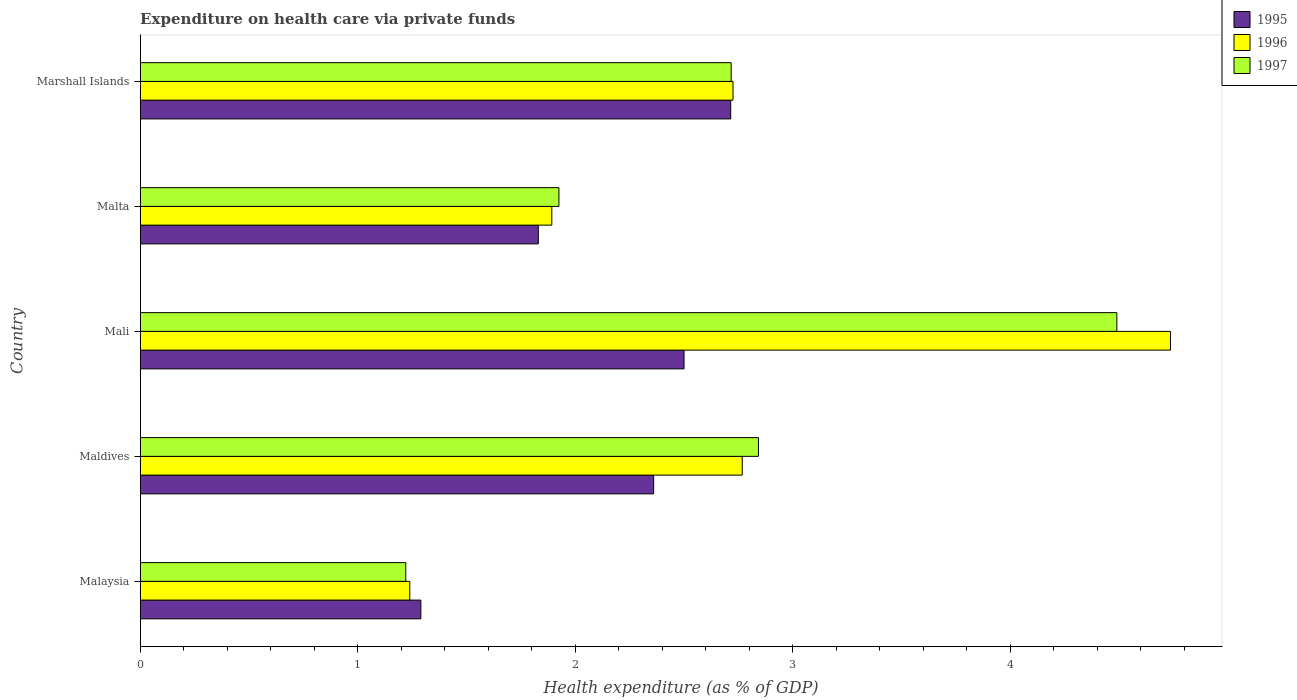How many different coloured bars are there?
Your answer should be very brief. 3. How many groups of bars are there?
Your answer should be very brief. 5. Are the number of bars on each tick of the Y-axis equal?
Your answer should be very brief. Yes. How many bars are there on the 5th tick from the bottom?
Provide a succinct answer. 3. What is the label of the 1st group of bars from the top?
Offer a terse response. Marshall Islands. In how many cases, is the number of bars for a given country not equal to the number of legend labels?
Your answer should be compact. 0. What is the expenditure made on health care in 1997 in Malta?
Offer a very short reply. 1.93. Across all countries, what is the maximum expenditure made on health care in 1997?
Your answer should be compact. 4.49. Across all countries, what is the minimum expenditure made on health care in 1996?
Provide a short and direct response. 1.24. In which country was the expenditure made on health care in 1996 maximum?
Your answer should be very brief. Mali. In which country was the expenditure made on health care in 1996 minimum?
Give a very brief answer. Malaysia. What is the total expenditure made on health care in 1997 in the graph?
Make the answer very short. 13.2. What is the difference between the expenditure made on health care in 1997 in Mali and that in Marshall Islands?
Ensure brevity in your answer.  1.77. What is the difference between the expenditure made on health care in 1996 in Marshall Islands and the expenditure made on health care in 1995 in Malaysia?
Give a very brief answer. 1.44. What is the average expenditure made on health care in 1996 per country?
Your answer should be very brief. 2.67. What is the difference between the expenditure made on health care in 1995 and expenditure made on health care in 1996 in Maldives?
Offer a very short reply. -0.41. In how many countries, is the expenditure made on health care in 1995 greater than 3 %?
Your response must be concise. 0. What is the ratio of the expenditure made on health care in 1996 in Malaysia to that in Maldives?
Your answer should be compact. 0.45. Is the difference between the expenditure made on health care in 1995 in Malaysia and Mali greater than the difference between the expenditure made on health care in 1996 in Malaysia and Mali?
Your answer should be very brief. Yes. What is the difference between the highest and the second highest expenditure made on health care in 1995?
Offer a very short reply. 0.21. What is the difference between the highest and the lowest expenditure made on health care in 1996?
Provide a short and direct response. 3.5. In how many countries, is the expenditure made on health care in 1997 greater than the average expenditure made on health care in 1997 taken over all countries?
Offer a very short reply. 3. Is it the case that in every country, the sum of the expenditure made on health care in 1996 and expenditure made on health care in 1995 is greater than the expenditure made on health care in 1997?
Make the answer very short. Yes. How many bars are there?
Offer a terse response. 15. Are all the bars in the graph horizontal?
Your response must be concise. Yes. How many countries are there in the graph?
Offer a terse response. 5. Does the graph contain grids?
Ensure brevity in your answer.  No. How are the legend labels stacked?
Your answer should be very brief. Vertical. What is the title of the graph?
Ensure brevity in your answer.  Expenditure on health care via private funds. Does "1983" appear as one of the legend labels in the graph?
Provide a succinct answer. No. What is the label or title of the X-axis?
Provide a short and direct response. Health expenditure (as % of GDP). What is the Health expenditure (as % of GDP) in 1995 in Malaysia?
Offer a very short reply. 1.29. What is the Health expenditure (as % of GDP) in 1996 in Malaysia?
Offer a terse response. 1.24. What is the Health expenditure (as % of GDP) of 1997 in Malaysia?
Ensure brevity in your answer.  1.22. What is the Health expenditure (as % of GDP) in 1995 in Maldives?
Ensure brevity in your answer.  2.36. What is the Health expenditure (as % of GDP) of 1996 in Maldives?
Offer a terse response. 2.77. What is the Health expenditure (as % of GDP) of 1997 in Maldives?
Offer a terse response. 2.84. What is the Health expenditure (as % of GDP) in 1995 in Mali?
Give a very brief answer. 2.5. What is the Health expenditure (as % of GDP) of 1996 in Mali?
Give a very brief answer. 4.74. What is the Health expenditure (as % of GDP) in 1997 in Mali?
Offer a terse response. 4.49. What is the Health expenditure (as % of GDP) of 1995 in Malta?
Provide a succinct answer. 1.83. What is the Health expenditure (as % of GDP) of 1996 in Malta?
Provide a short and direct response. 1.89. What is the Health expenditure (as % of GDP) of 1997 in Malta?
Make the answer very short. 1.93. What is the Health expenditure (as % of GDP) in 1995 in Marshall Islands?
Keep it short and to the point. 2.72. What is the Health expenditure (as % of GDP) of 1996 in Marshall Islands?
Your answer should be very brief. 2.73. What is the Health expenditure (as % of GDP) in 1997 in Marshall Islands?
Offer a terse response. 2.72. Across all countries, what is the maximum Health expenditure (as % of GDP) of 1995?
Provide a succinct answer. 2.72. Across all countries, what is the maximum Health expenditure (as % of GDP) in 1996?
Your answer should be compact. 4.74. Across all countries, what is the maximum Health expenditure (as % of GDP) of 1997?
Offer a terse response. 4.49. Across all countries, what is the minimum Health expenditure (as % of GDP) in 1995?
Give a very brief answer. 1.29. Across all countries, what is the minimum Health expenditure (as % of GDP) of 1996?
Provide a succinct answer. 1.24. Across all countries, what is the minimum Health expenditure (as % of GDP) of 1997?
Make the answer very short. 1.22. What is the total Health expenditure (as % of GDP) of 1995 in the graph?
Keep it short and to the point. 10.7. What is the total Health expenditure (as % of GDP) in 1996 in the graph?
Offer a very short reply. 13.36. What is the total Health expenditure (as % of GDP) in 1997 in the graph?
Offer a terse response. 13.2. What is the difference between the Health expenditure (as % of GDP) of 1995 in Malaysia and that in Maldives?
Keep it short and to the point. -1.07. What is the difference between the Health expenditure (as % of GDP) in 1996 in Malaysia and that in Maldives?
Your answer should be very brief. -1.53. What is the difference between the Health expenditure (as % of GDP) of 1997 in Malaysia and that in Maldives?
Make the answer very short. -1.62. What is the difference between the Health expenditure (as % of GDP) of 1995 in Malaysia and that in Mali?
Your response must be concise. -1.21. What is the difference between the Health expenditure (as % of GDP) in 1996 in Malaysia and that in Mali?
Provide a succinct answer. -3.5. What is the difference between the Health expenditure (as % of GDP) of 1997 in Malaysia and that in Mali?
Your answer should be compact. -3.27. What is the difference between the Health expenditure (as % of GDP) in 1995 in Malaysia and that in Malta?
Offer a terse response. -0.54. What is the difference between the Health expenditure (as % of GDP) of 1996 in Malaysia and that in Malta?
Offer a terse response. -0.65. What is the difference between the Health expenditure (as % of GDP) in 1997 in Malaysia and that in Malta?
Your answer should be compact. -0.7. What is the difference between the Health expenditure (as % of GDP) in 1995 in Malaysia and that in Marshall Islands?
Your response must be concise. -1.42. What is the difference between the Health expenditure (as % of GDP) of 1996 in Malaysia and that in Marshall Islands?
Give a very brief answer. -1.49. What is the difference between the Health expenditure (as % of GDP) in 1997 in Malaysia and that in Marshall Islands?
Your answer should be compact. -1.5. What is the difference between the Health expenditure (as % of GDP) in 1995 in Maldives and that in Mali?
Offer a very short reply. -0.14. What is the difference between the Health expenditure (as % of GDP) of 1996 in Maldives and that in Mali?
Make the answer very short. -1.97. What is the difference between the Health expenditure (as % of GDP) of 1997 in Maldives and that in Mali?
Your answer should be compact. -1.65. What is the difference between the Health expenditure (as % of GDP) in 1995 in Maldives and that in Malta?
Keep it short and to the point. 0.53. What is the difference between the Health expenditure (as % of GDP) in 1996 in Maldives and that in Malta?
Keep it short and to the point. 0.88. What is the difference between the Health expenditure (as % of GDP) in 1997 in Maldives and that in Malta?
Offer a very short reply. 0.92. What is the difference between the Health expenditure (as % of GDP) of 1995 in Maldives and that in Marshall Islands?
Keep it short and to the point. -0.35. What is the difference between the Health expenditure (as % of GDP) in 1996 in Maldives and that in Marshall Islands?
Keep it short and to the point. 0.04. What is the difference between the Health expenditure (as % of GDP) in 1997 in Maldives and that in Marshall Islands?
Make the answer very short. 0.13. What is the difference between the Health expenditure (as % of GDP) of 1995 in Mali and that in Malta?
Offer a terse response. 0.67. What is the difference between the Health expenditure (as % of GDP) of 1996 in Mali and that in Malta?
Give a very brief answer. 2.84. What is the difference between the Health expenditure (as % of GDP) of 1997 in Mali and that in Malta?
Offer a very short reply. 2.57. What is the difference between the Health expenditure (as % of GDP) in 1995 in Mali and that in Marshall Islands?
Your response must be concise. -0.21. What is the difference between the Health expenditure (as % of GDP) of 1996 in Mali and that in Marshall Islands?
Offer a very short reply. 2.01. What is the difference between the Health expenditure (as % of GDP) in 1997 in Mali and that in Marshall Islands?
Give a very brief answer. 1.77. What is the difference between the Health expenditure (as % of GDP) of 1995 in Malta and that in Marshall Islands?
Give a very brief answer. -0.88. What is the difference between the Health expenditure (as % of GDP) in 1996 in Malta and that in Marshall Islands?
Make the answer very short. -0.83. What is the difference between the Health expenditure (as % of GDP) of 1997 in Malta and that in Marshall Islands?
Keep it short and to the point. -0.79. What is the difference between the Health expenditure (as % of GDP) in 1995 in Malaysia and the Health expenditure (as % of GDP) in 1996 in Maldives?
Offer a very short reply. -1.48. What is the difference between the Health expenditure (as % of GDP) of 1995 in Malaysia and the Health expenditure (as % of GDP) of 1997 in Maldives?
Your answer should be very brief. -1.55. What is the difference between the Health expenditure (as % of GDP) of 1996 in Malaysia and the Health expenditure (as % of GDP) of 1997 in Maldives?
Your answer should be very brief. -1.6. What is the difference between the Health expenditure (as % of GDP) of 1995 in Malaysia and the Health expenditure (as % of GDP) of 1996 in Mali?
Make the answer very short. -3.45. What is the difference between the Health expenditure (as % of GDP) of 1995 in Malaysia and the Health expenditure (as % of GDP) of 1997 in Mali?
Provide a succinct answer. -3.2. What is the difference between the Health expenditure (as % of GDP) of 1996 in Malaysia and the Health expenditure (as % of GDP) of 1997 in Mali?
Offer a very short reply. -3.25. What is the difference between the Health expenditure (as % of GDP) in 1995 in Malaysia and the Health expenditure (as % of GDP) in 1996 in Malta?
Ensure brevity in your answer.  -0.6. What is the difference between the Health expenditure (as % of GDP) of 1995 in Malaysia and the Health expenditure (as % of GDP) of 1997 in Malta?
Offer a very short reply. -0.63. What is the difference between the Health expenditure (as % of GDP) in 1996 in Malaysia and the Health expenditure (as % of GDP) in 1997 in Malta?
Your answer should be very brief. -0.69. What is the difference between the Health expenditure (as % of GDP) in 1995 in Malaysia and the Health expenditure (as % of GDP) in 1996 in Marshall Islands?
Ensure brevity in your answer.  -1.44. What is the difference between the Health expenditure (as % of GDP) of 1995 in Malaysia and the Health expenditure (as % of GDP) of 1997 in Marshall Islands?
Your answer should be very brief. -1.43. What is the difference between the Health expenditure (as % of GDP) of 1996 in Malaysia and the Health expenditure (as % of GDP) of 1997 in Marshall Islands?
Give a very brief answer. -1.48. What is the difference between the Health expenditure (as % of GDP) in 1995 in Maldives and the Health expenditure (as % of GDP) in 1996 in Mali?
Offer a terse response. -2.38. What is the difference between the Health expenditure (as % of GDP) of 1995 in Maldives and the Health expenditure (as % of GDP) of 1997 in Mali?
Offer a terse response. -2.13. What is the difference between the Health expenditure (as % of GDP) in 1996 in Maldives and the Health expenditure (as % of GDP) in 1997 in Mali?
Offer a very short reply. -1.72. What is the difference between the Health expenditure (as % of GDP) in 1995 in Maldives and the Health expenditure (as % of GDP) in 1996 in Malta?
Provide a short and direct response. 0.47. What is the difference between the Health expenditure (as % of GDP) of 1995 in Maldives and the Health expenditure (as % of GDP) of 1997 in Malta?
Provide a short and direct response. 0.44. What is the difference between the Health expenditure (as % of GDP) of 1996 in Maldives and the Health expenditure (as % of GDP) of 1997 in Malta?
Your answer should be very brief. 0.84. What is the difference between the Health expenditure (as % of GDP) in 1995 in Maldives and the Health expenditure (as % of GDP) in 1996 in Marshall Islands?
Your answer should be compact. -0.36. What is the difference between the Health expenditure (as % of GDP) in 1995 in Maldives and the Health expenditure (as % of GDP) in 1997 in Marshall Islands?
Offer a terse response. -0.36. What is the difference between the Health expenditure (as % of GDP) of 1996 in Maldives and the Health expenditure (as % of GDP) of 1997 in Marshall Islands?
Your response must be concise. 0.05. What is the difference between the Health expenditure (as % of GDP) in 1995 in Mali and the Health expenditure (as % of GDP) in 1996 in Malta?
Make the answer very short. 0.61. What is the difference between the Health expenditure (as % of GDP) in 1995 in Mali and the Health expenditure (as % of GDP) in 1997 in Malta?
Make the answer very short. 0.58. What is the difference between the Health expenditure (as % of GDP) in 1996 in Mali and the Health expenditure (as % of GDP) in 1997 in Malta?
Offer a very short reply. 2.81. What is the difference between the Health expenditure (as % of GDP) in 1995 in Mali and the Health expenditure (as % of GDP) in 1996 in Marshall Islands?
Offer a very short reply. -0.23. What is the difference between the Health expenditure (as % of GDP) in 1995 in Mali and the Health expenditure (as % of GDP) in 1997 in Marshall Islands?
Offer a terse response. -0.22. What is the difference between the Health expenditure (as % of GDP) in 1996 in Mali and the Health expenditure (as % of GDP) in 1997 in Marshall Islands?
Your answer should be very brief. 2.02. What is the difference between the Health expenditure (as % of GDP) in 1995 in Malta and the Health expenditure (as % of GDP) in 1996 in Marshall Islands?
Offer a very short reply. -0.9. What is the difference between the Health expenditure (as % of GDP) of 1995 in Malta and the Health expenditure (as % of GDP) of 1997 in Marshall Islands?
Your answer should be compact. -0.89. What is the difference between the Health expenditure (as % of GDP) in 1996 in Malta and the Health expenditure (as % of GDP) in 1997 in Marshall Islands?
Your response must be concise. -0.82. What is the average Health expenditure (as % of GDP) in 1995 per country?
Make the answer very short. 2.14. What is the average Health expenditure (as % of GDP) of 1996 per country?
Give a very brief answer. 2.67. What is the average Health expenditure (as % of GDP) in 1997 per country?
Your answer should be very brief. 2.64. What is the difference between the Health expenditure (as % of GDP) in 1995 and Health expenditure (as % of GDP) in 1996 in Malaysia?
Your response must be concise. 0.05. What is the difference between the Health expenditure (as % of GDP) of 1995 and Health expenditure (as % of GDP) of 1997 in Malaysia?
Provide a succinct answer. 0.07. What is the difference between the Health expenditure (as % of GDP) in 1996 and Health expenditure (as % of GDP) in 1997 in Malaysia?
Provide a succinct answer. 0.02. What is the difference between the Health expenditure (as % of GDP) in 1995 and Health expenditure (as % of GDP) in 1996 in Maldives?
Ensure brevity in your answer.  -0.41. What is the difference between the Health expenditure (as % of GDP) of 1995 and Health expenditure (as % of GDP) of 1997 in Maldives?
Provide a succinct answer. -0.48. What is the difference between the Health expenditure (as % of GDP) in 1996 and Health expenditure (as % of GDP) in 1997 in Maldives?
Give a very brief answer. -0.07. What is the difference between the Health expenditure (as % of GDP) of 1995 and Health expenditure (as % of GDP) of 1996 in Mali?
Your response must be concise. -2.24. What is the difference between the Health expenditure (as % of GDP) in 1995 and Health expenditure (as % of GDP) in 1997 in Mali?
Offer a very short reply. -1.99. What is the difference between the Health expenditure (as % of GDP) in 1996 and Health expenditure (as % of GDP) in 1997 in Mali?
Your response must be concise. 0.25. What is the difference between the Health expenditure (as % of GDP) of 1995 and Health expenditure (as % of GDP) of 1996 in Malta?
Keep it short and to the point. -0.06. What is the difference between the Health expenditure (as % of GDP) in 1995 and Health expenditure (as % of GDP) in 1997 in Malta?
Keep it short and to the point. -0.09. What is the difference between the Health expenditure (as % of GDP) in 1996 and Health expenditure (as % of GDP) in 1997 in Malta?
Give a very brief answer. -0.03. What is the difference between the Health expenditure (as % of GDP) in 1995 and Health expenditure (as % of GDP) in 1996 in Marshall Islands?
Give a very brief answer. -0.01. What is the difference between the Health expenditure (as % of GDP) in 1995 and Health expenditure (as % of GDP) in 1997 in Marshall Islands?
Offer a terse response. -0. What is the difference between the Health expenditure (as % of GDP) of 1996 and Health expenditure (as % of GDP) of 1997 in Marshall Islands?
Your answer should be very brief. 0.01. What is the ratio of the Health expenditure (as % of GDP) of 1995 in Malaysia to that in Maldives?
Keep it short and to the point. 0.55. What is the ratio of the Health expenditure (as % of GDP) in 1996 in Malaysia to that in Maldives?
Make the answer very short. 0.45. What is the ratio of the Health expenditure (as % of GDP) in 1997 in Malaysia to that in Maldives?
Offer a very short reply. 0.43. What is the ratio of the Health expenditure (as % of GDP) in 1995 in Malaysia to that in Mali?
Ensure brevity in your answer.  0.52. What is the ratio of the Health expenditure (as % of GDP) of 1996 in Malaysia to that in Mali?
Offer a very short reply. 0.26. What is the ratio of the Health expenditure (as % of GDP) of 1997 in Malaysia to that in Mali?
Your response must be concise. 0.27. What is the ratio of the Health expenditure (as % of GDP) in 1995 in Malaysia to that in Malta?
Give a very brief answer. 0.7. What is the ratio of the Health expenditure (as % of GDP) of 1996 in Malaysia to that in Malta?
Ensure brevity in your answer.  0.65. What is the ratio of the Health expenditure (as % of GDP) of 1997 in Malaysia to that in Malta?
Provide a short and direct response. 0.63. What is the ratio of the Health expenditure (as % of GDP) in 1995 in Malaysia to that in Marshall Islands?
Give a very brief answer. 0.48. What is the ratio of the Health expenditure (as % of GDP) of 1996 in Malaysia to that in Marshall Islands?
Give a very brief answer. 0.45. What is the ratio of the Health expenditure (as % of GDP) of 1997 in Malaysia to that in Marshall Islands?
Provide a short and direct response. 0.45. What is the ratio of the Health expenditure (as % of GDP) in 1995 in Maldives to that in Mali?
Your answer should be very brief. 0.94. What is the ratio of the Health expenditure (as % of GDP) in 1996 in Maldives to that in Mali?
Your response must be concise. 0.58. What is the ratio of the Health expenditure (as % of GDP) in 1997 in Maldives to that in Mali?
Ensure brevity in your answer.  0.63. What is the ratio of the Health expenditure (as % of GDP) of 1995 in Maldives to that in Malta?
Provide a succinct answer. 1.29. What is the ratio of the Health expenditure (as % of GDP) in 1996 in Maldives to that in Malta?
Your answer should be compact. 1.46. What is the ratio of the Health expenditure (as % of GDP) of 1997 in Maldives to that in Malta?
Provide a short and direct response. 1.48. What is the ratio of the Health expenditure (as % of GDP) in 1995 in Maldives to that in Marshall Islands?
Offer a very short reply. 0.87. What is the ratio of the Health expenditure (as % of GDP) in 1996 in Maldives to that in Marshall Islands?
Your answer should be compact. 1.02. What is the ratio of the Health expenditure (as % of GDP) of 1997 in Maldives to that in Marshall Islands?
Provide a short and direct response. 1.05. What is the ratio of the Health expenditure (as % of GDP) in 1995 in Mali to that in Malta?
Make the answer very short. 1.37. What is the ratio of the Health expenditure (as % of GDP) of 1996 in Mali to that in Malta?
Ensure brevity in your answer.  2.5. What is the ratio of the Health expenditure (as % of GDP) in 1997 in Mali to that in Malta?
Make the answer very short. 2.33. What is the ratio of the Health expenditure (as % of GDP) of 1995 in Mali to that in Marshall Islands?
Ensure brevity in your answer.  0.92. What is the ratio of the Health expenditure (as % of GDP) in 1996 in Mali to that in Marshall Islands?
Your answer should be compact. 1.74. What is the ratio of the Health expenditure (as % of GDP) in 1997 in Mali to that in Marshall Islands?
Your response must be concise. 1.65. What is the ratio of the Health expenditure (as % of GDP) in 1995 in Malta to that in Marshall Islands?
Keep it short and to the point. 0.67. What is the ratio of the Health expenditure (as % of GDP) of 1996 in Malta to that in Marshall Islands?
Make the answer very short. 0.69. What is the ratio of the Health expenditure (as % of GDP) of 1997 in Malta to that in Marshall Islands?
Provide a short and direct response. 0.71. What is the difference between the highest and the second highest Health expenditure (as % of GDP) in 1995?
Provide a succinct answer. 0.21. What is the difference between the highest and the second highest Health expenditure (as % of GDP) in 1996?
Your answer should be very brief. 1.97. What is the difference between the highest and the second highest Health expenditure (as % of GDP) of 1997?
Offer a terse response. 1.65. What is the difference between the highest and the lowest Health expenditure (as % of GDP) of 1995?
Your answer should be very brief. 1.42. What is the difference between the highest and the lowest Health expenditure (as % of GDP) of 1996?
Give a very brief answer. 3.5. What is the difference between the highest and the lowest Health expenditure (as % of GDP) in 1997?
Keep it short and to the point. 3.27. 